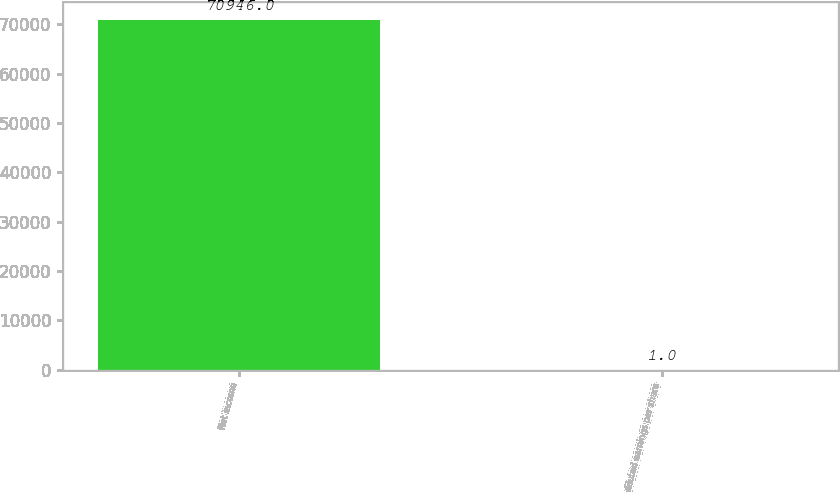Convert chart to OTSL. <chart><loc_0><loc_0><loc_500><loc_500><bar_chart><fcel>Net income<fcel>diluted earnings per share<nl><fcel>70946<fcel>1<nl></chart> 